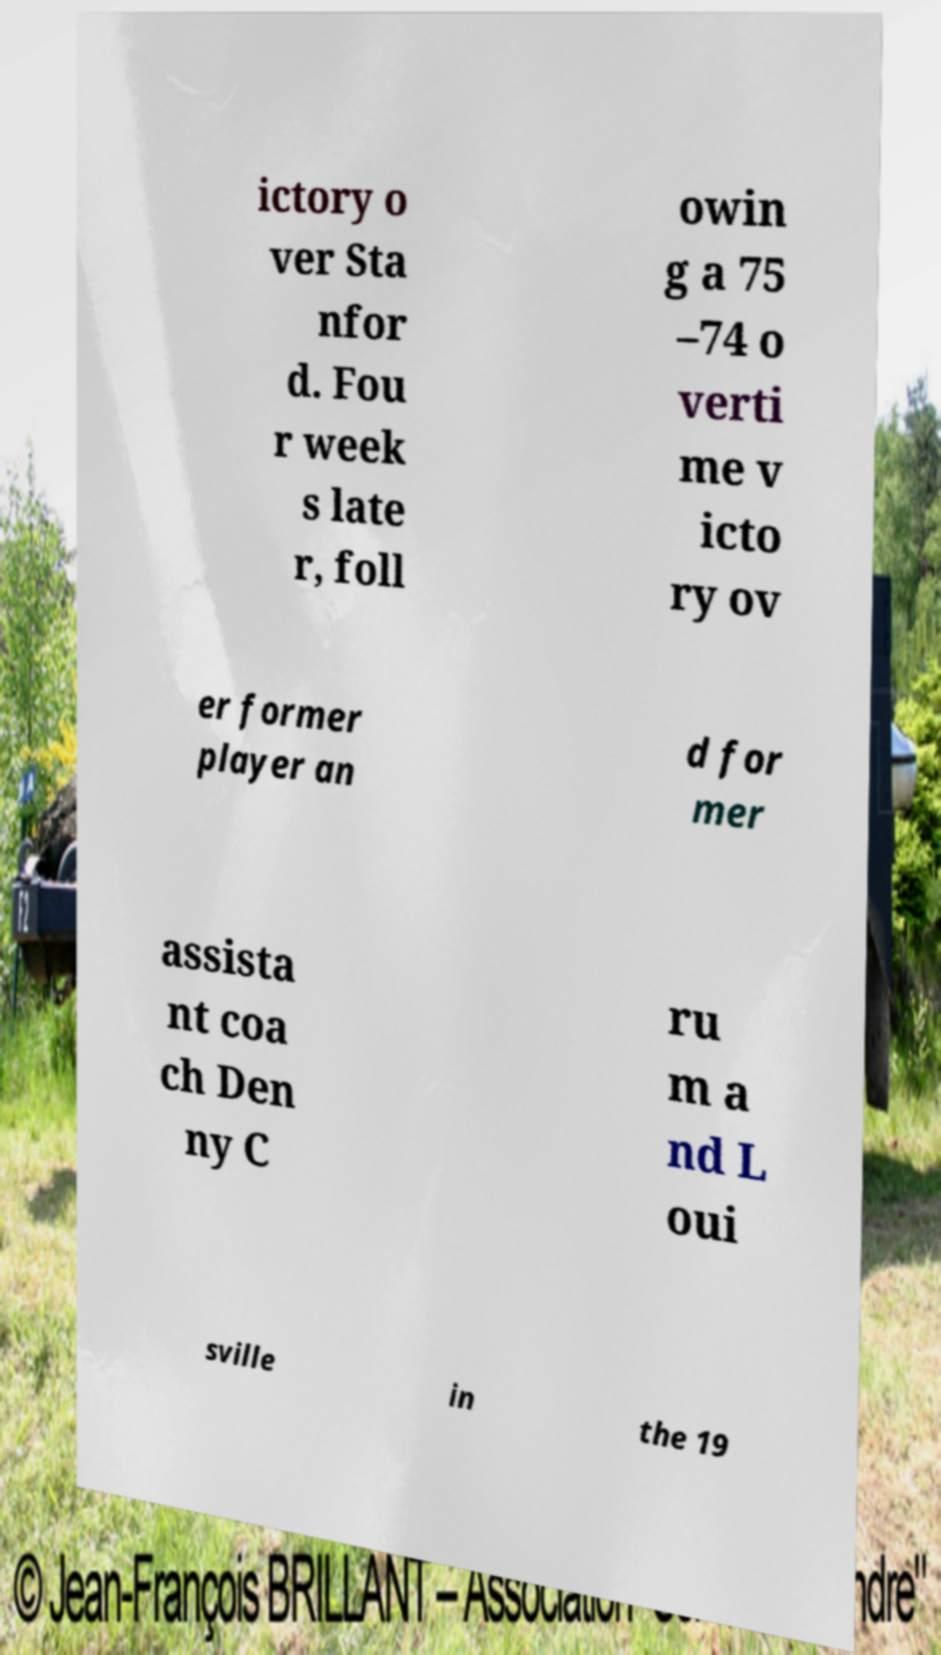For documentation purposes, I need the text within this image transcribed. Could you provide that? ictory o ver Sta nfor d. Fou r week s late r, foll owin g a 75 –74 o verti me v icto ry ov er former player an d for mer assista nt coa ch Den ny C ru m a nd L oui sville in the 19 